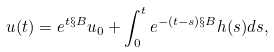<formula> <loc_0><loc_0><loc_500><loc_500>u ( t ) = e ^ { t \S B } u _ { 0 } + \int _ { 0 } ^ { t } e ^ { - ( t - s ) \S B } h ( s ) d s ,</formula> 